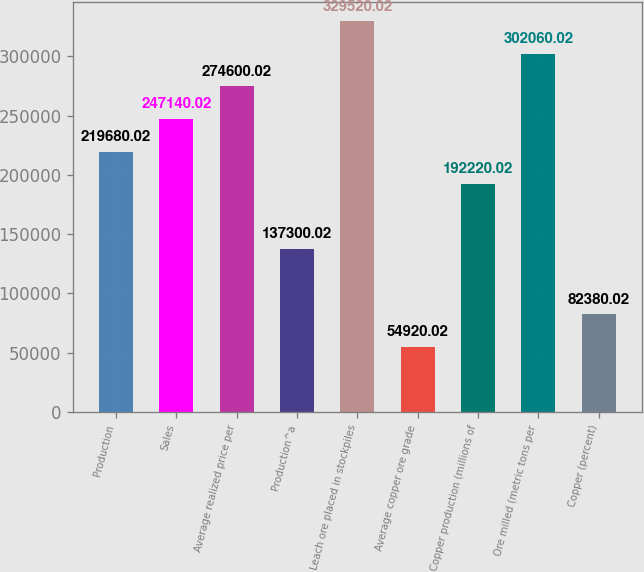Convert chart. <chart><loc_0><loc_0><loc_500><loc_500><bar_chart><fcel>Production<fcel>Sales<fcel>Average realized price per<fcel>Production^a<fcel>Leach ore placed in stockpiles<fcel>Average copper ore grade<fcel>Copper production (millions of<fcel>Ore milled (metric tons per<fcel>Copper (percent)<nl><fcel>219680<fcel>247140<fcel>274600<fcel>137300<fcel>329520<fcel>54920<fcel>192220<fcel>302060<fcel>82380<nl></chart> 